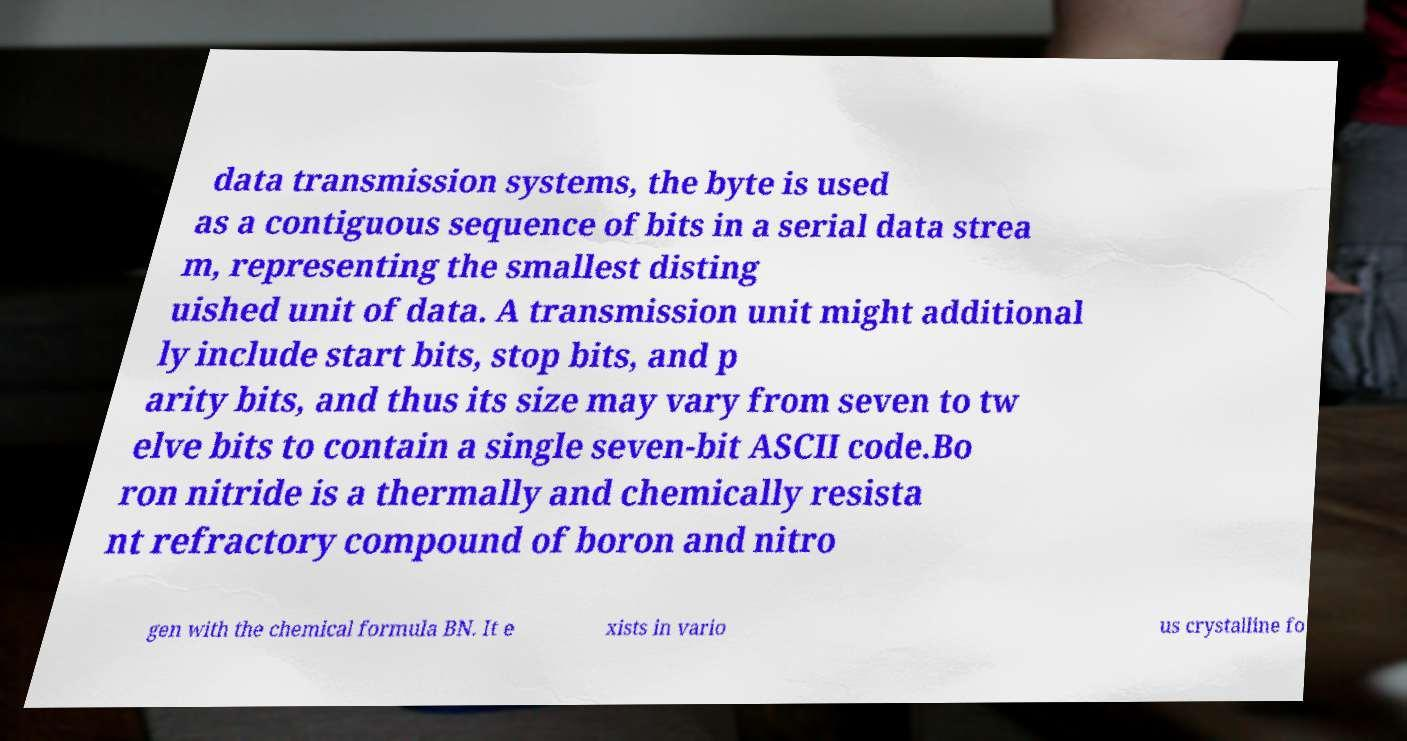I need the written content from this picture converted into text. Can you do that? data transmission systems, the byte is used as a contiguous sequence of bits in a serial data strea m, representing the smallest disting uished unit of data. A transmission unit might additional ly include start bits, stop bits, and p arity bits, and thus its size may vary from seven to tw elve bits to contain a single seven-bit ASCII code.Bo ron nitride is a thermally and chemically resista nt refractory compound of boron and nitro gen with the chemical formula BN. It e xists in vario us crystalline fo 